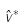Convert formula to latex. <formula><loc_0><loc_0><loc_500><loc_500>\hat { v } ^ { * }</formula> 